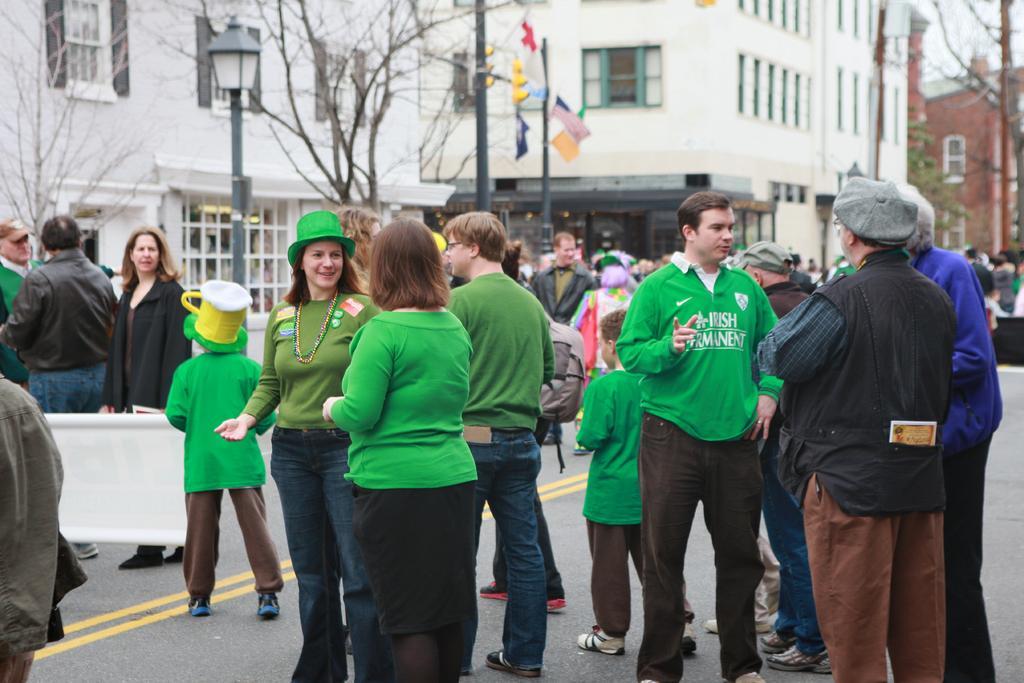Please provide a concise description of this image. In the foreground I can see a crowd on the road. In the background I can see buildings, windows, light poles, trees and boards. This image is taken during a day. 